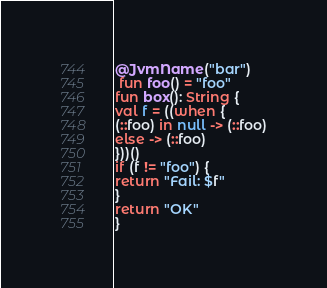Convert code to text. <code><loc_0><loc_0><loc_500><loc_500><_Kotlin_>@JvmName("bar")
 fun foo() = "foo"
fun box(): String {
val f = ((when {
(::foo) in null -> (::foo)
else -> (::foo)
}))()
if (f != "foo") {
return "Fail: $f"
}
return "OK"
}</code> 